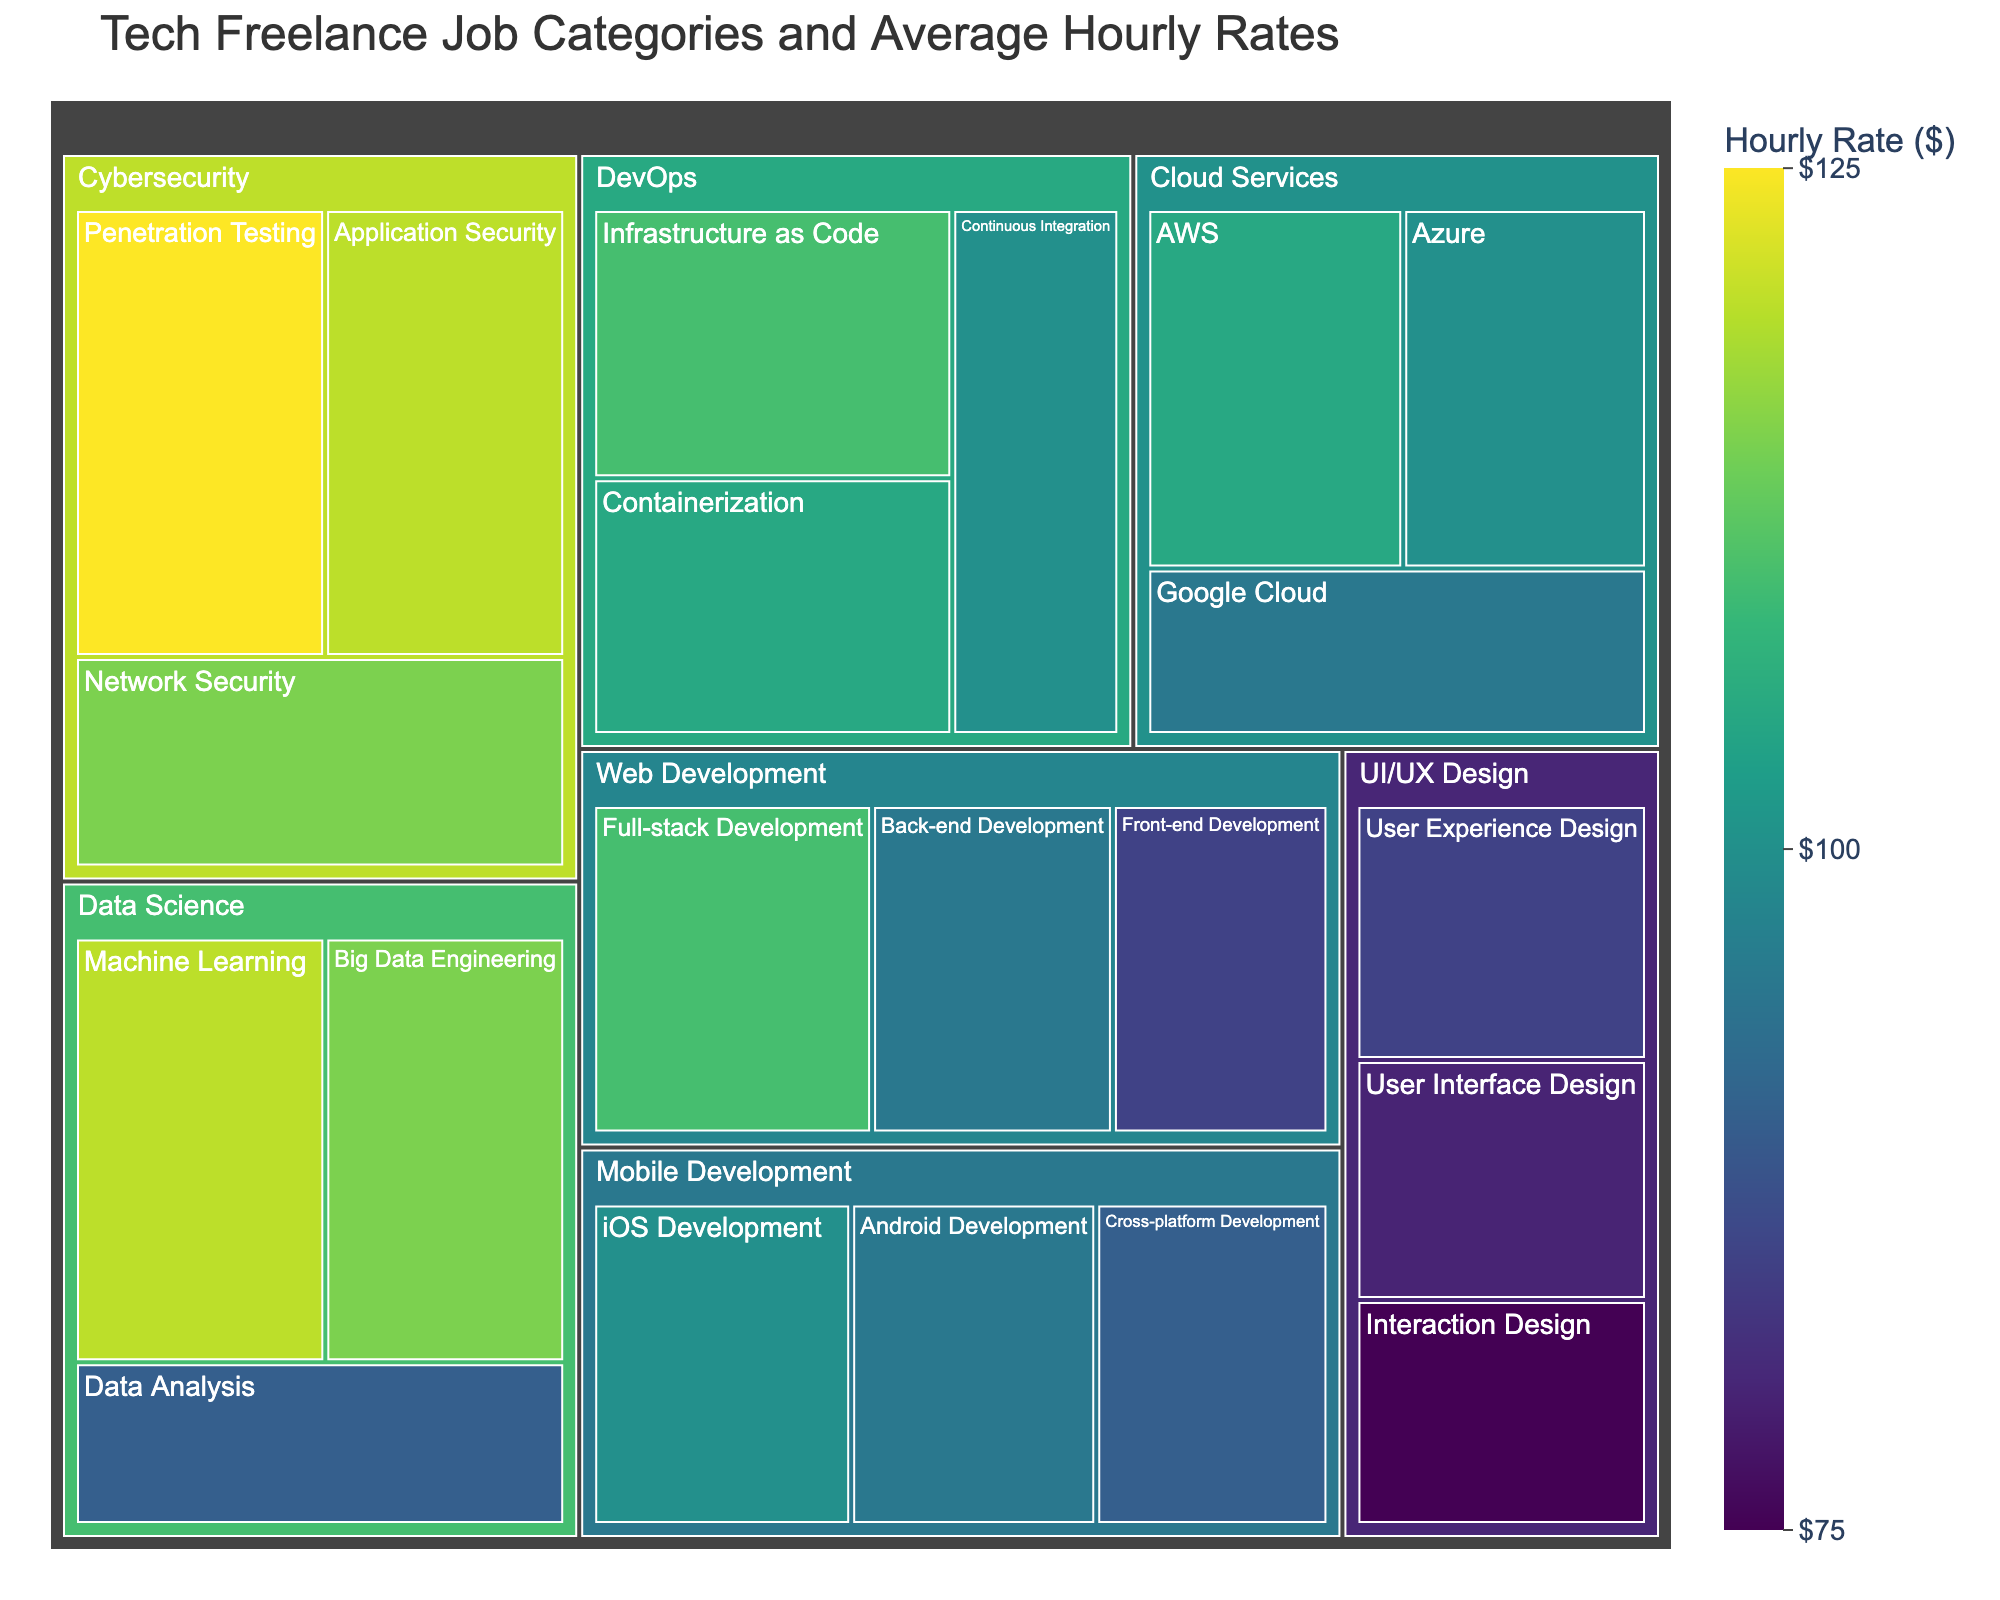What's the title of the figure? The title is displayed at the top of the treemap and usually gives a good summary of what the data represents. Here, it shows "Tech Freelance Job Categories and Average Hourly Rates"
Answer: Tech Freelance Job Categories and Average Hourly Rates What subcategory in 'DevOps' has the highest average hourly rate? Look at the 'DevOps' category and identify the subcategory with the highest value. From the provided data, 'Infrastructure as Code' has an hourly rate of $110, which is the highest in DevOps
Answer: Infrastructure as Code Which job category has the highest average hourly rate? Identify the highest value from all categories and subcategories. 'Penetration Testing' in the Cybersecurity category has the highest rate at $125
Answer: Cybersecurity How many subcategories are there in the 'Data Science' category? Count the number of subcategories listed under 'Data Science'. From the data, there are three: 'Data Analysis', 'Machine Learning', and 'Big Data Engineering'
Answer: 3 What is the average hourly rate across all 'Cloud Services' subcategories? Take the hourly rates of all 'Cloud Services' subcategories (AWS, Azure, Google Cloud: 105, 100, 95), sum them up (105 + 100 + 95 = 300), and divide by the number of subcategories (3). 300 / 3 = 100
Answer: 100 Between 'iOS Development' and 'Android Development', which has the higher hourly rate? Compare the hourly rates of 'iOS Development' (100) and 'Android Development' (95). 'iOS Development' has the higher rate
Answer: iOS Development In the 'UI/UX Design' category, what is the difference in hourly rate between the highest and lowest subcategories? Identify the highest and lowest values in 'UI/UX Design': 'User Experience Design' (85) and 'Interaction Design' (75), then find the difference (85 - 75 = 10)
Answer: 10 What's the combined hourly rate for 'Machine Learning' and 'Penetration Testing'? Add the hourly rates of 'Machine Learning' (120) and 'Penetration Testing' (125): 120 + 125 = 245
Answer: 245 Which subcategory within 'Web Development' offers the highest average hourly rate? Identify the subcategory in 'Web Development' with the highest value. 'Full-stack Development' has an hourly rate of $110
Answer: Full-stack Development 